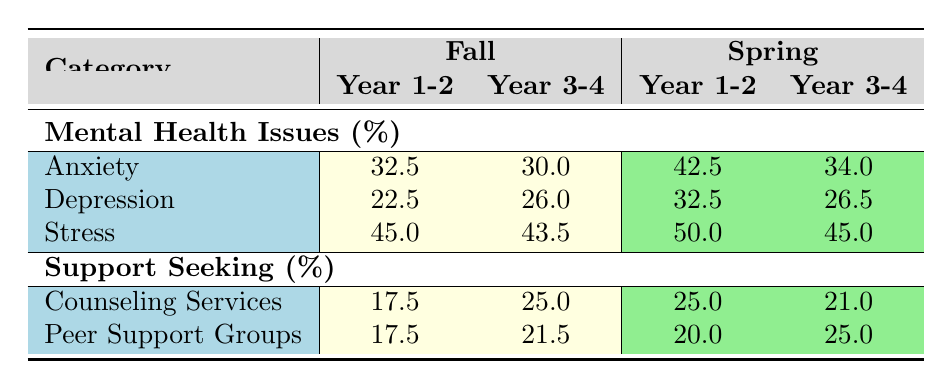What is the percentage of students reporting anxiety in Year 1-2 during the Fall semester? From the table, the percentage of students reporting anxiety in Year 1-2 for the Fall semester is provided as 32.5%.
Answer: 32.5% What is the highest percentage of depression reported by any demographic across both semesters? By examining the table, the percentage of depression reported for Year 2 in the Spring semester is 35%, which is higher than all other values.
Answer: 35% What is the combined percentage of peer support group usage for Year 3-4 in both semesters? First, we find the percentage for Year 3-4 in Fall, which is 21.5% and in Spring, which is 25.0%. Combining these, we calculate 21.5 + 25.0 = 46.5%.
Answer: 46.5% Did more students seek counseling services in the Spring or the Fall semester for Year 1-2? Examining the counseling services percentages, Year 1-2 in Spring shows 25.0% while in Fall it's 17.5%. Thus, more students sought counseling services in Spring.
Answer: Yes What is the average percentage of stress reported by Year 1-2 across both semesters? The stress percentage for Year 1-2 in Fall is 45.0% and in Spring is 50.0%. To find the average, we calculate (45.0 + 50.0) / 2 = 47.5%.
Answer: 47.5% Which demographic had the lowest percentage of anxiety reported in the Spring semester? The table indicates Year 3 had 30% anxiety in Spring, which is the lowest compared to Year 1 (40%), Year 2 (45%), and Year 4 (38%).
Answer: Year 3 Is the support-seeking percentage for counseling services higher for Year 3-4 in Fall or Spring? For Year 3-4 in Fall, the counseling services percentage is 25.0% and in Spring, it's 21.0%. Since 25.0% is higher, Fall has more support-seeking.
Answer: Fall If we consider the percentages of stress for Year 3-4 in both semesters, what is the difference? The percentage of stress for Year 3-4 in Fall is 43.5% and in Spring is 45.0%. The difference is 45.0% - 43.5% = 1.5%.
Answer: 1.5% 